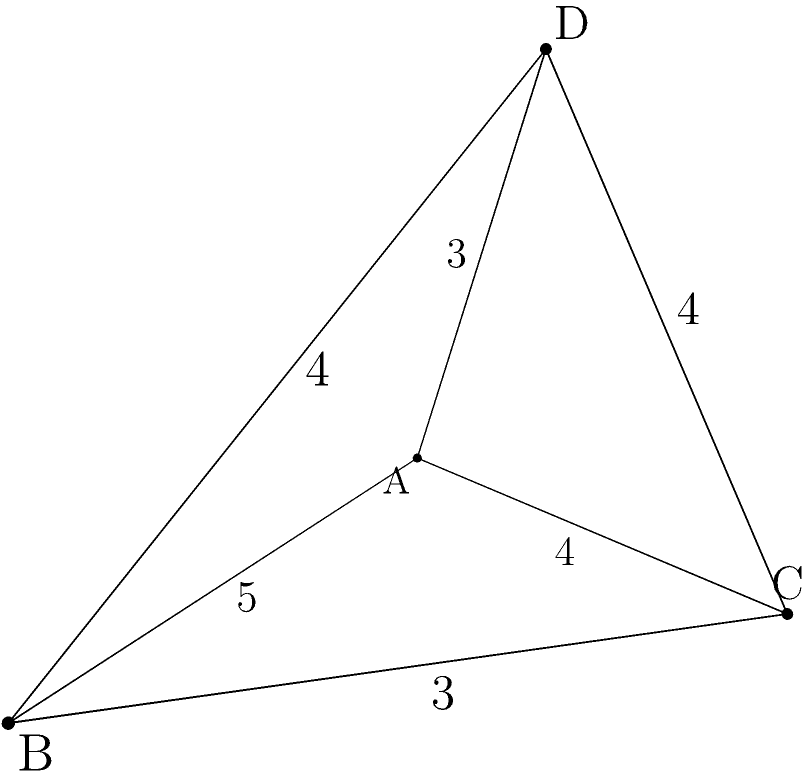Given an irregular tetrahedron ABCD with edge lengths AB = 5, AC = 4, BC = 3, AD = 3, BD = 4, and CD = 4, prove that its volume V can be calculated using the formula:

$$V = \frac{1}{12}\sqrt{-a^2b^2c^2 + a^2b^2d^2 + a^2c^2e^2 + b^2c^2f^2 + a^2d^2e^2 + b^2d^2f^2 + c^2e^2f^2 - d^2e^2f^2}$$

where a, b, c, d, e, and f are the lengths of the edges of the tetrahedron. Then, calculate the volume of the given tetrahedron. To prove the formula and calculate the volume, we'll follow these steps:

1) First, let's recall Cayley-Menger determinant for the volume of a tetrahedron:

   $$V^2 = \frac{1}{288}\begin{vmatrix} 
   0 & 1 & 1 & 1 & 1 \\
   1 & 0 & a^2 & b^2 & c^2 \\
   1 & a^2 & 0 & d^2 & e^2 \\
   1 & b^2 & d^2 & 0 & f^2 \\
   1 & c^2 & e^2 & f^2 & 0
   \end{vmatrix}$$

2) Expanding this determinant (which is a lengthy process), we get:

   $$V^2 = \frac{1}{288}(-a^2b^2c^2 + a^2b^2d^2 + a^2c^2e^2 + b^2c^2f^2 + a^2d^2e^2 + b^2d^2f^2 + c^2e^2f^2 - d^2e^2f^2)$$

3) Taking the square root of both sides:

   $$V = \frac{1}{12}\sqrt{-a^2b^2c^2 + a^2b^2d^2 + a^2c^2e^2 + b^2c^2f^2 + a^2d^2e^2 + b^2d^2f^2 + c^2e^2f^2 - d^2e^2f^2}$$

   This proves the given formula.

4) Now, let's substitute the given edge lengths into the formula:
   a = 5 (AB), b = 4 (AC), c = 3 (BC), d = 3 (AD), e = 4 (BD), f = 4 (CD)

5) Plugging these values into the formula:

   $$V = \frac{1}{12}\sqrt{-5^2\cdot4^2\cdot3^2 + 5^2\cdot4^2\cdot3^2 + 5^2\cdot3^2\cdot4^2 + 4^2\cdot3^2\cdot4^2 + 5^2\cdot3^2\cdot4^2 + 4^2\cdot3^2\cdot4^2 + 3^2\cdot4^2\cdot4^2 - 3^2\cdot4^2\cdot4^2}$$

6) Simplifying:

   $$V = \frac{1}{12}\sqrt{-3600 + 3600 + 7200 + 2304 + 7200 + 2304 + 2304 - 2304}$$
   $$V = \frac{1}{12}\sqrt{21008}$$
   $$V = \frac{\sqrt{21008}}{12}$$

7) Simplifying further:

   $$V = \frac{\sqrt{2101\cdot8}}{12} = \frac{\sqrt{2101}\cdot\sqrt{8}}{12} = \frac{\sqrt{2101}\cdot2\sqrt{2}}{12} = \frac{\sqrt{2101}\cdot\sqrt{2}}{6}$$

Therefore, the volume of the tetrahedron is $\frac{\sqrt{2101}\cdot\sqrt{2}}{6}$ cubic units.
Answer: $\frac{\sqrt{2101}\cdot\sqrt{2}}{6}$ cubic units 